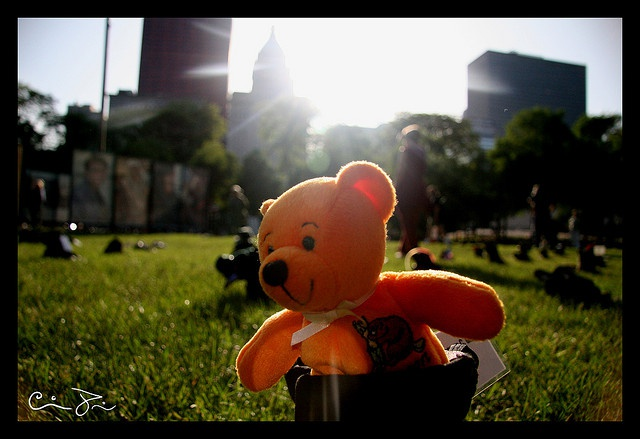Describe the objects in this image and their specific colors. I can see teddy bear in black, maroon, and brown tones, people in black, gray, and darkgray tones, people in black tones, people in black, olive, and gray tones, and people in black and gray tones in this image. 